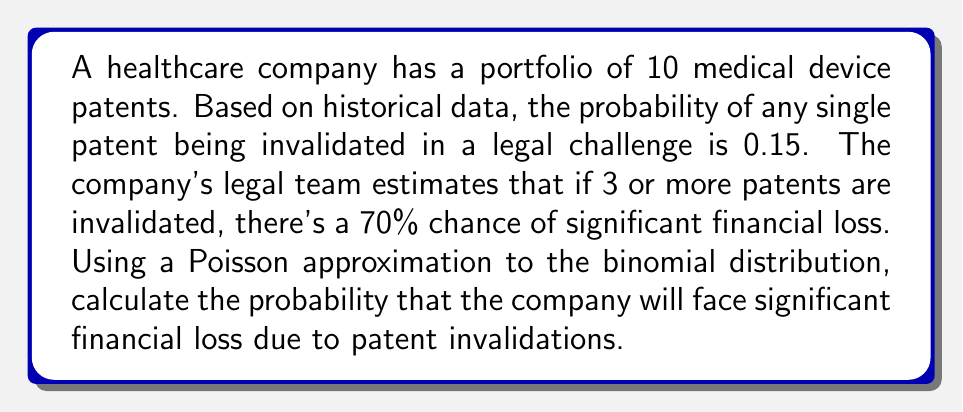Can you solve this math problem? Let's approach this step-by-step:

1) First, we need to calculate the expected number of patent invalidations:
   $\lambda = np = 10 \times 0.15 = 1.5$

2) We'll use the Poisson distribution with $\lambda = 1.5$ to approximate the probability of 3 or more invalidations.

3) The probability of significant financial loss is:
   $P(\text{loss}) = P(X \geq 3) \times 0.7$

   Where $X$ is the number of invalidated patents.

4) We can calculate $P(X \geq 3)$ as:
   $P(X \geq 3) = 1 - P(X < 3) = 1 - [P(X=0) + P(X=1) + P(X=2)]$

5) Using the Poisson probability mass function:
   $P(X=k) = \frac{e^{-\lambda}\lambda^k}{k!}$

6) Let's calculate each term:
   $P(X=0) = \frac{e^{-1.5}1.5^0}{0!} = e^{-1.5} \approx 0.2231$
   
   $P(X=1) = \frac{e^{-1.5}1.5^1}{1!} = 1.5e^{-1.5} \approx 0.3347$
   
   $P(X=2) = \frac{e^{-1.5}1.5^2}{2!} = \frac{1.5^2}{2}e^{-1.5} \approx 0.2510$

7) Therefore:
   $P(X \geq 3) = 1 - (0.2231 + 0.3347 + 0.2510) = 0.1912$

8) Finally:
   $P(\text{loss}) = 0.1912 \times 0.7 = 0.1338$
Answer: 0.1338 or 13.38% 